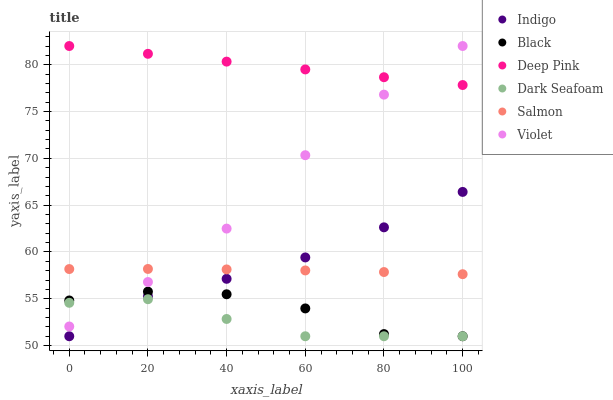Does Dark Seafoam have the minimum area under the curve?
Answer yes or no. Yes. Does Deep Pink have the maximum area under the curve?
Answer yes or no. Yes. Does Indigo have the minimum area under the curve?
Answer yes or no. No. Does Indigo have the maximum area under the curve?
Answer yes or no. No. Is Deep Pink the smoothest?
Answer yes or no. Yes. Is Black the roughest?
Answer yes or no. Yes. Is Indigo the smoothest?
Answer yes or no. No. Is Indigo the roughest?
Answer yes or no. No. Does Indigo have the lowest value?
Answer yes or no. Yes. Does Salmon have the lowest value?
Answer yes or no. No. Does Violet have the highest value?
Answer yes or no. Yes. Does Indigo have the highest value?
Answer yes or no. No. Is Indigo less than Violet?
Answer yes or no. Yes. Is Violet greater than Indigo?
Answer yes or no. Yes. Does Salmon intersect Violet?
Answer yes or no. Yes. Is Salmon less than Violet?
Answer yes or no. No. Is Salmon greater than Violet?
Answer yes or no. No. Does Indigo intersect Violet?
Answer yes or no. No. 